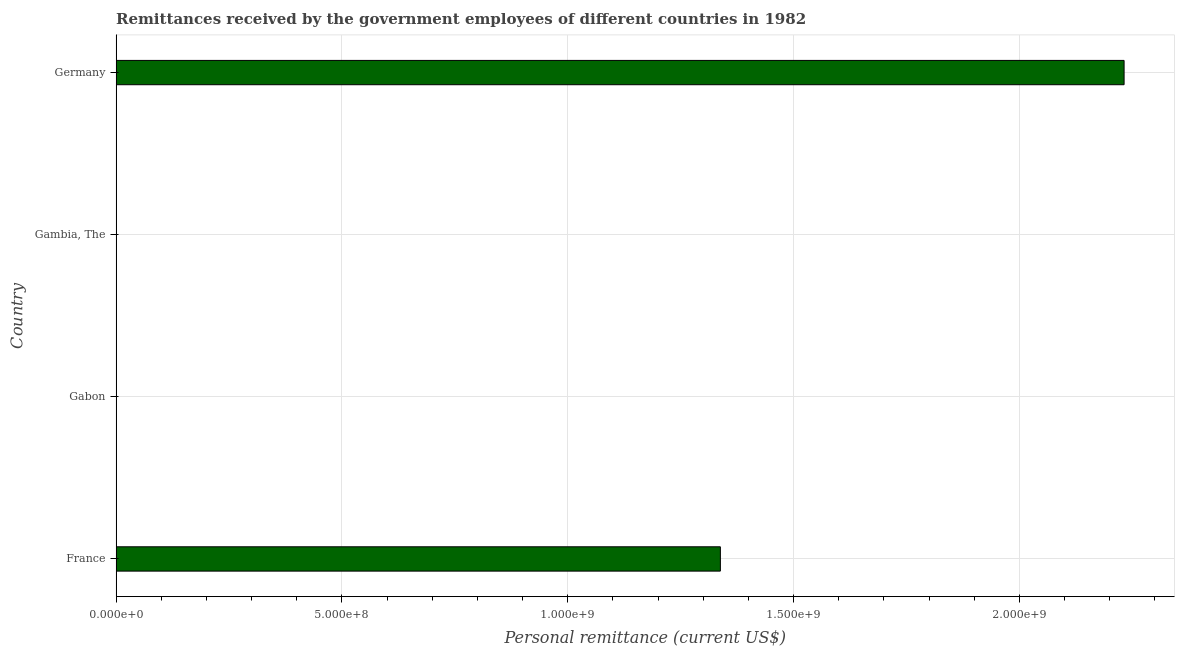What is the title of the graph?
Your answer should be compact. Remittances received by the government employees of different countries in 1982. What is the label or title of the X-axis?
Your answer should be compact. Personal remittance (current US$). What is the label or title of the Y-axis?
Ensure brevity in your answer.  Country. What is the personal remittances in Germany?
Provide a succinct answer. 2.23e+09. Across all countries, what is the maximum personal remittances?
Offer a terse response. 2.23e+09. Across all countries, what is the minimum personal remittances?
Offer a very short reply. 6.09e+04. In which country was the personal remittances maximum?
Your response must be concise. Germany. In which country was the personal remittances minimum?
Offer a terse response. Gabon. What is the sum of the personal remittances?
Offer a terse response. 3.57e+09. What is the difference between the personal remittances in Gabon and Germany?
Give a very brief answer. -2.23e+09. What is the average personal remittances per country?
Offer a terse response. 8.92e+08. What is the median personal remittances?
Make the answer very short. 6.69e+08. What is the ratio of the personal remittances in France to that in Germany?
Provide a succinct answer. 0.6. What is the difference between the highest and the second highest personal remittances?
Your response must be concise. 8.94e+08. What is the difference between the highest and the lowest personal remittances?
Your response must be concise. 2.23e+09. In how many countries, is the personal remittances greater than the average personal remittances taken over all countries?
Offer a terse response. 2. How many countries are there in the graph?
Give a very brief answer. 4. What is the difference between two consecutive major ticks on the X-axis?
Your response must be concise. 5.00e+08. Are the values on the major ticks of X-axis written in scientific E-notation?
Provide a succinct answer. Yes. What is the Personal remittance (current US$) in France?
Keep it short and to the point. 1.34e+09. What is the Personal remittance (current US$) in Gabon?
Provide a short and direct response. 6.09e+04. What is the Personal remittance (current US$) in Gambia, The?
Your response must be concise. 1.88e+05. What is the Personal remittance (current US$) of Germany?
Your response must be concise. 2.23e+09. What is the difference between the Personal remittance (current US$) in France and Gabon?
Offer a terse response. 1.34e+09. What is the difference between the Personal remittance (current US$) in France and Gambia, The?
Make the answer very short. 1.34e+09. What is the difference between the Personal remittance (current US$) in France and Germany?
Make the answer very short. -8.94e+08. What is the difference between the Personal remittance (current US$) in Gabon and Gambia, The?
Ensure brevity in your answer.  -1.27e+05. What is the difference between the Personal remittance (current US$) in Gabon and Germany?
Keep it short and to the point. -2.23e+09. What is the difference between the Personal remittance (current US$) in Gambia, The and Germany?
Your answer should be compact. -2.23e+09. What is the ratio of the Personal remittance (current US$) in France to that in Gabon?
Offer a terse response. 2.20e+04. What is the ratio of the Personal remittance (current US$) in France to that in Gambia, The?
Provide a short and direct response. 7123.49. What is the ratio of the Personal remittance (current US$) in France to that in Germany?
Your answer should be compact. 0.6. What is the ratio of the Personal remittance (current US$) in Gabon to that in Gambia, The?
Keep it short and to the point. 0.32. What is the ratio of the Personal remittance (current US$) in Gabon to that in Germany?
Offer a very short reply. 0. What is the ratio of the Personal remittance (current US$) in Gambia, The to that in Germany?
Your response must be concise. 0. 